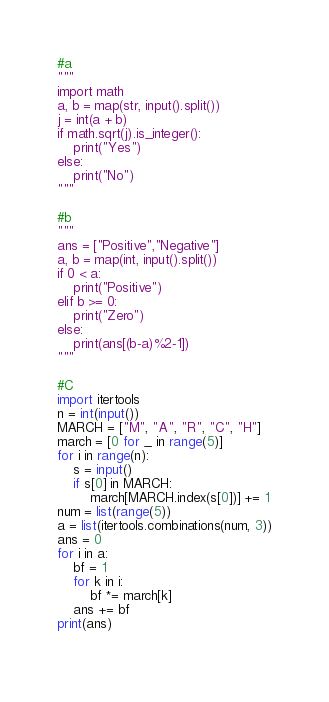Convert code to text. <code><loc_0><loc_0><loc_500><loc_500><_Python_>#a
"""
import math
a, b = map(str, input().split())
j = int(a + b)
if math.sqrt(j).is_integer():
    print("Yes")
else:
    print("No")
"""

#b
"""
ans = ["Positive","Negative"]
a, b = map(int, input().split())
if 0 < a:
    print("Positive")
elif b >= 0:
    print("Zero")
else:
    print(ans[(b-a)%2-1])
"""

#C
import itertools
n = int(input())
MARCH = ["M", "A", "R", "C", "H"]
march = [0 for _ in range(5)]
for i in range(n):
    s = input()
    if s[0] in MARCH:
        march[MARCH.index(s[0])] += 1
num = list(range(5))
a = list(itertools.combinations(num, 3))
ans = 0
for i in a:
    bf = 1
    for k in i:
        bf *= march[k]
    ans += bf
print(ans)
        
</code> 